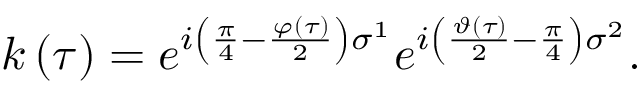Convert formula to latex. <formula><loc_0><loc_0><loc_500><loc_500>k \left ( \tau \right ) = e ^ { i \left ( \frac { \pi } { 4 } - \frac { \varphi \left ( \tau \right ) } { 2 } \right ) \sigma ^ { 1 } } e ^ { i \left ( \frac { \vartheta \left ( \tau \right ) } { 2 } - \frac { \pi } { 4 } \right ) \sigma ^ { 2 } } .</formula> 